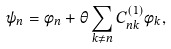Convert formula to latex. <formula><loc_0><loc_0><loc_500><loc_500>\psi _ { n } = \phi _ { n } + \theta \sum _ { k \neq n } C ^ { ( 1 ) } _ { n k } \phi _ { k } ,</formula> 